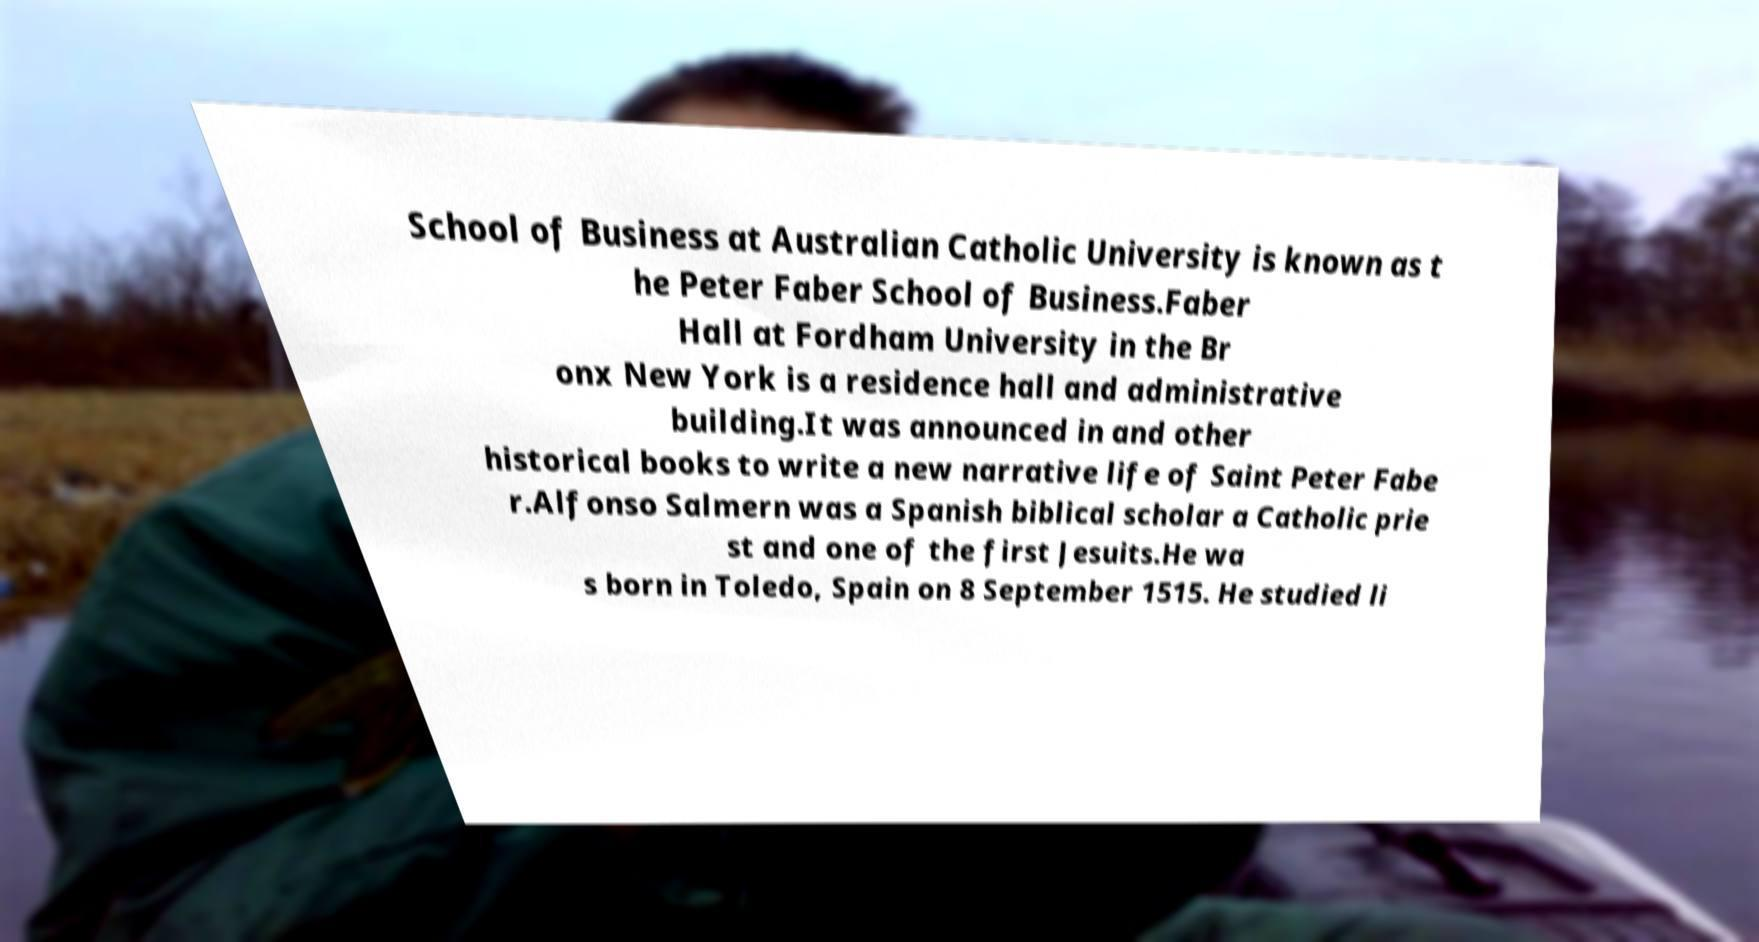Please identify and transcribe the text found in this image. School of Business at Australian Catholic University is known as t he Peter Faber School of Business.Faber Hall at Fordham University in the Br onx New York is a residence hall and administrative building.It was announced in and other historical books to write a new narrative life of Saint Peter Fabe r.Alfonso Salmern was a Spanish biblical scholar a Catholic prie st and one of the first Jesuits.He wa s born in Toledo, Spain on 8 September 1515. He studied li 